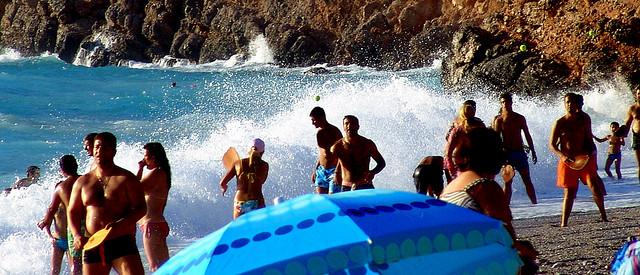What is the gender of the person with the ball cap on?
Quick response, please. Male. Where are the people?
Answer briefly. Beach. Are any of these people overweight?
Write a very short answer. Yes. 